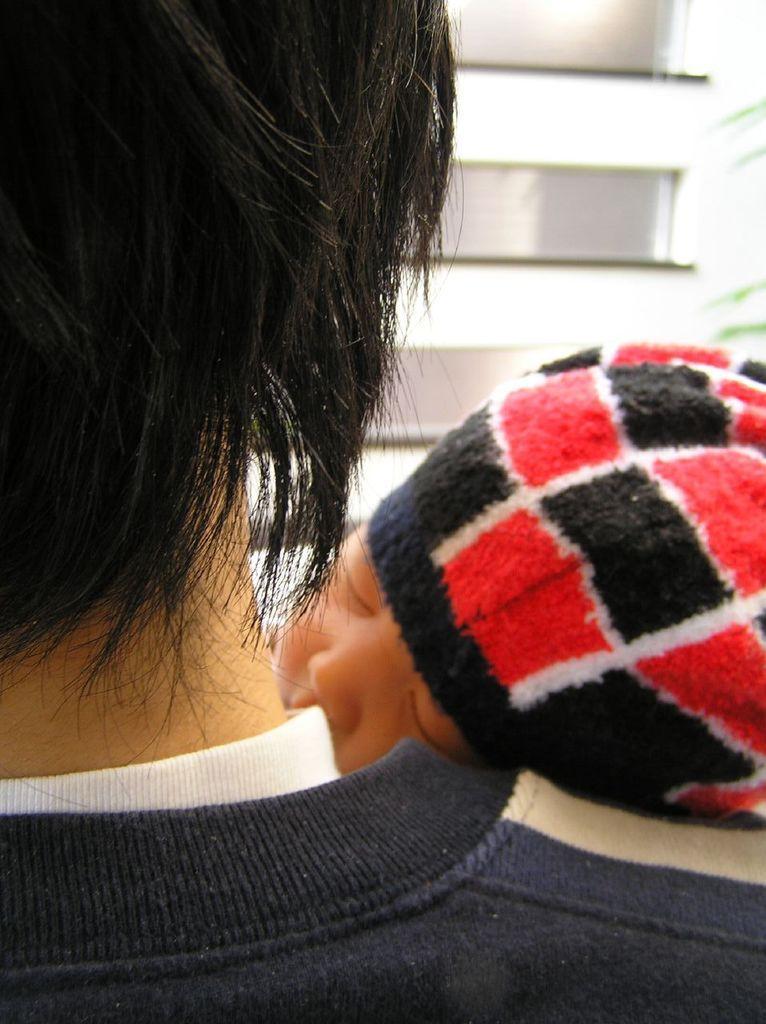Describe this image in one or two sentences. In this image we can see a baby sleeping on the shoulder of a person. 